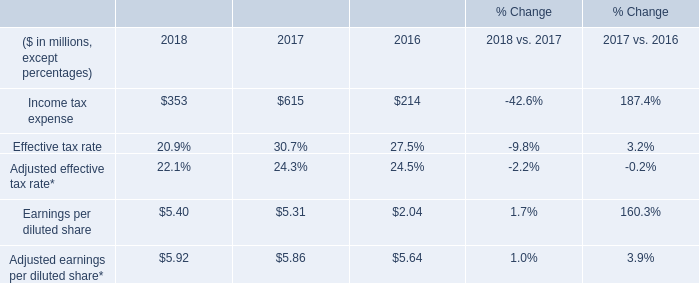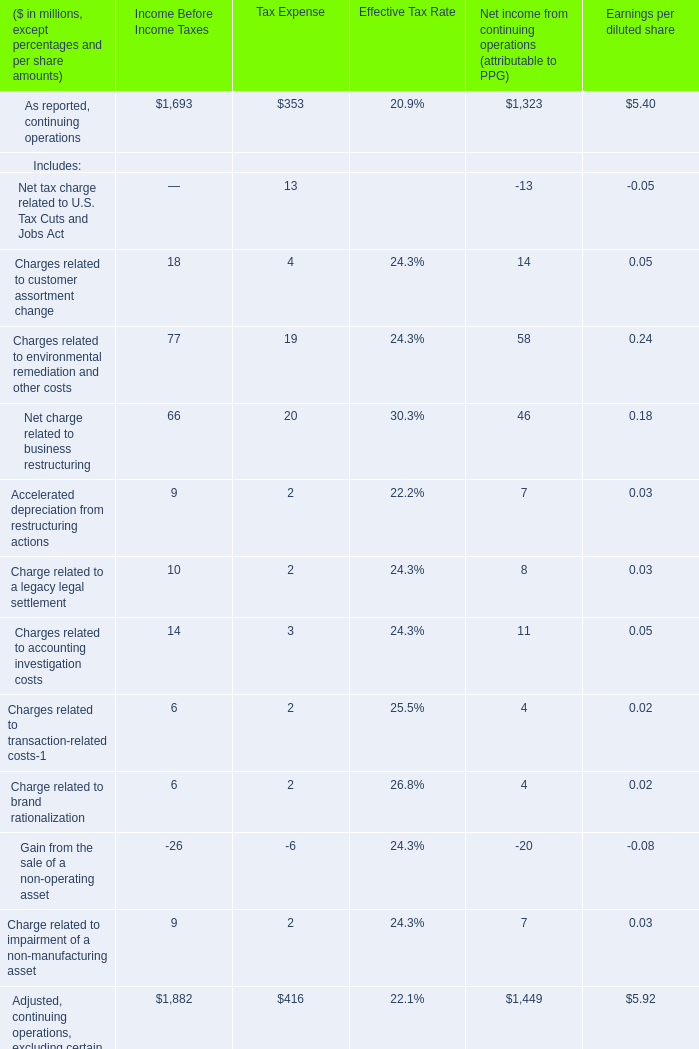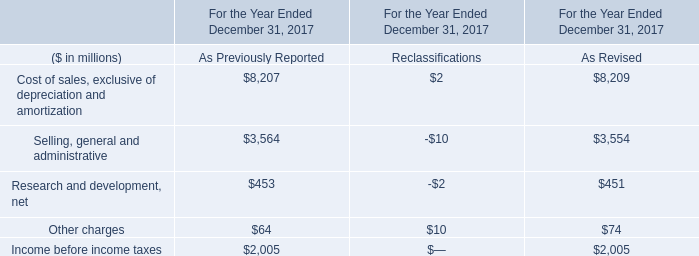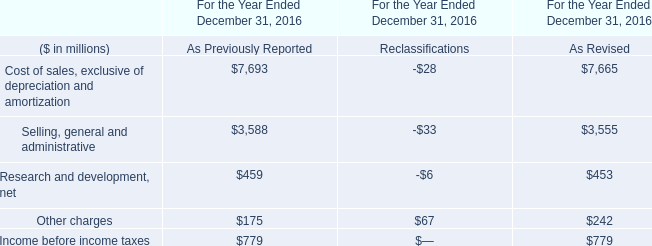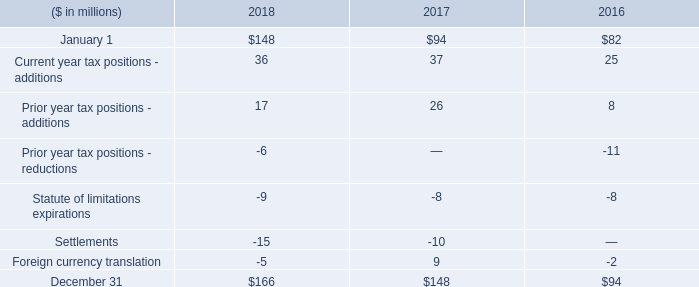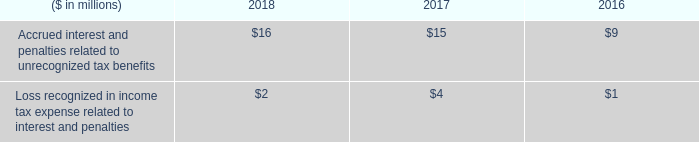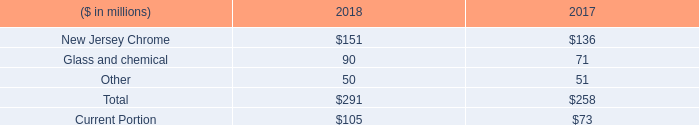What is the sum of Income tax expense in 2017 and Accrued interest and penalties related to unrecognized tax benefits in 2018? (in million) 
Computations: (615 + 16)
Answer: 631.0. 